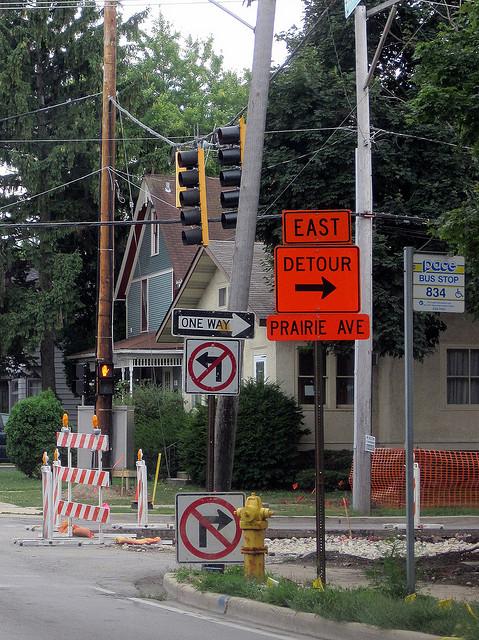Is the street busy?
Quick response, please. No. Is the pic upside down?
Write a very short answer. No. Are they in a city?
Keep it brief. Yes. Which directions must you turn?
Write a very short answer. Right. How many poles are visible?
Give a very brief answer. 6. What language is the street sign?
Write a very short answer. English. Is the hydrant red?
Short answer required. No. What color is the street sign?
Answer briefly. Orange. What color is the bright item?
Be succinct. Orange. What country is this?
Be succinct. United states. Does the word 'nation' appear?
Answer briefly. No. Is this in the United States?
Give a very brief answer. Yes. How many directions can you turn at this traffic light?
Quick response, please. 1. What condition is this road in?
Be succinct. Bad. What is paradoxically broken about this picture?
Write a very short answer. Signs contradict each other. What does the red sign say?
Quick response, please. East detour prairie ave. What happened to the traffic light sign?
Write a very short answer. Detour. Which way can you go?
Be succinct. Right. What language is on the signs?
Quick response, please. English. Is there a crowd?
Give a very brief answer. No. What street corner is this?
Concise answer only. Prairie ave. What direction can you not turn?
Keep it brief. Left. 